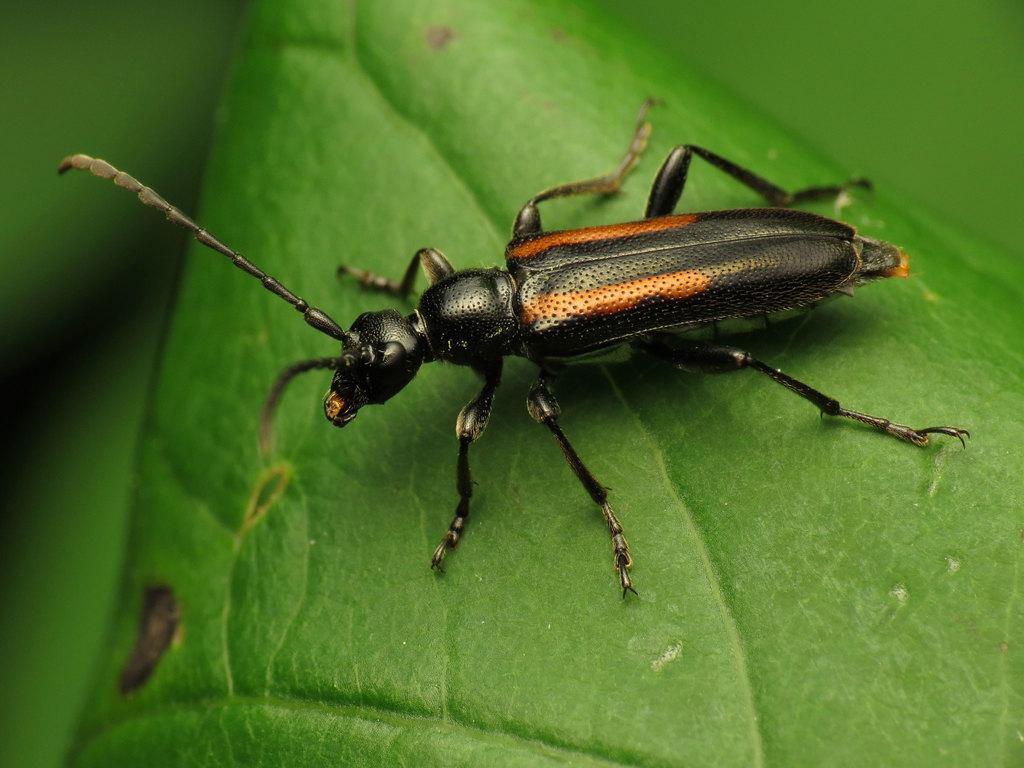Can you describe this image briefly? In this picture I can see there is an insect on the leaf and it has a body, head and legs. The backdrop of the image is blurred. 